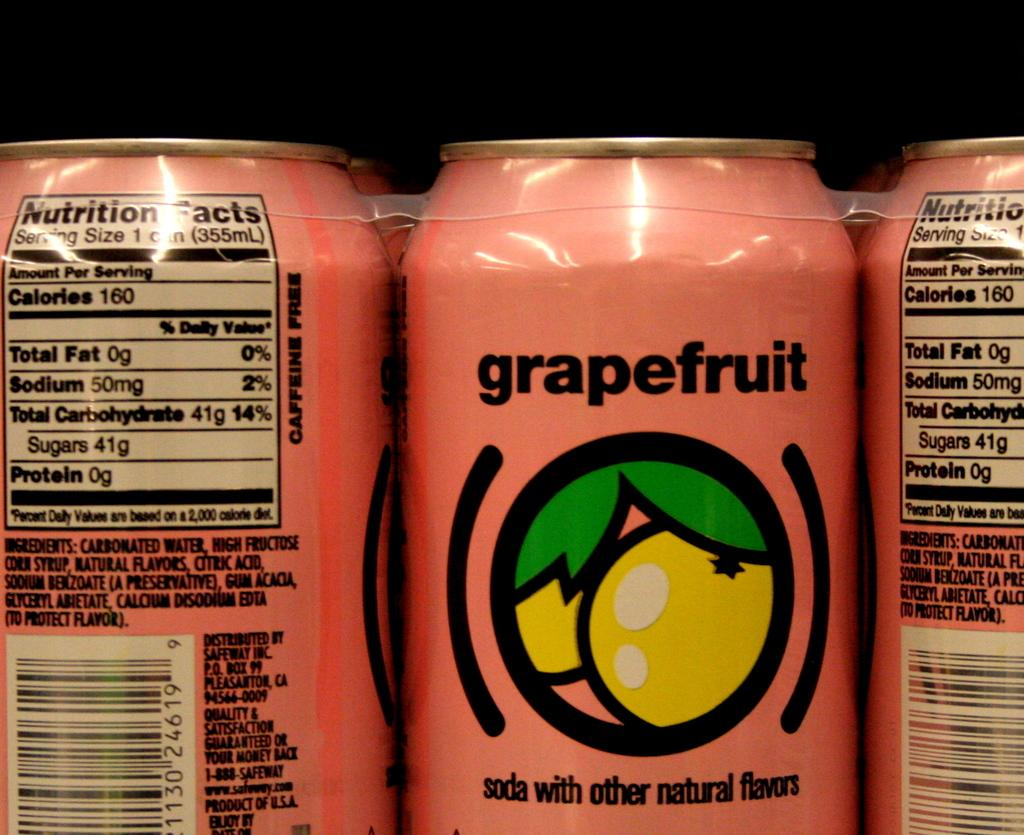<image>
Offer a succinct explanation of the picture presented. a pack of pink grapefruit soda cans together 